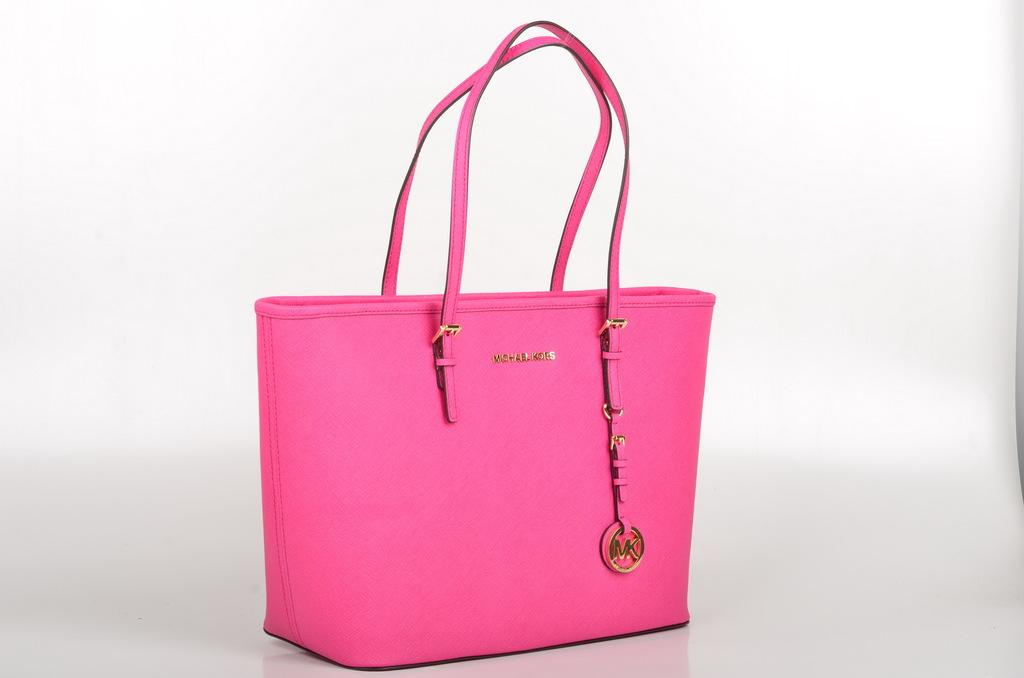What color is the handbag in the image? The handbag in the image is pink. What type of item is the pink object in the image? It is a women's handbag. What reason does the handbag give for crossing the border in the image? The handbag does not give any reason for crossing a border, as it is an inanimate object and cannot speak or have intentions. 